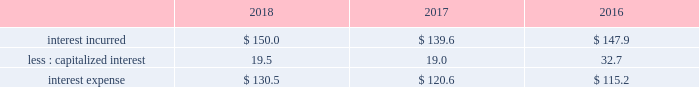Goodwill and intangible asset impairment charge during the third quarter of fiscal year 2017 , we determined that the goodwill and indefinite-lived intangible assets ( primarily acquired trade names ) associated with our latin america reporting unit of our industrial gases 2013 americas segment were impaired .
We recorded a noncash impairment charge of $ 162.1 ( $ 154.1 attributable to air products , after-tax , or $ .70 per share ) , which was driven by lower economic growth and profitability in the region .
This impairment charge has been excluded from segment results .
Refer to note 10 , goodwill , and note 11 , intangible assets , to the consolidated financial statements for additional information .
Other income ( expense ) , net items recorded to "other income ( expense ) , net" arise from transactions and events not directly related to our principal income earning activities .
The detail of "other income ( expense ) , net" is presented in note 23 , supplemental information , to the consolidated financial statements .
2018 vs .
2017 other income ( expense ) , net of $ 50.2 decreased $ 70.8 , primarily due to lower income from the transition services agreements with versum and evonik , lower income from the sale of assets and investments , lower favorable contract settlements , and an unfavorable foreign exchange impact .
2017 vs .
2016 other income ( expense ) , net of $ 121.0 increased $ 71.6 , primarily due to income from transition services agreements with versum and evonik , income from the sale of assets and investments , including a gain of $ 12.2 ( $ 7.6 after-tax , or $ .03 per share ) resulting from the sale of a parcel of land , and a favorable foreign exchange impact .
Interest expense .
2018 vs .
2017 interest incurred increased $ 10.4 as project financing associated with the lu'an joint venture and a higher average interest rate on the debt portfolio were partially offset by the impact from a lower average debt balance .
The change in capitalized interest was driven by an increase in the carrying value of projects under construction .
2017 vs .
2016 interest incurred decreased $ 8.3 as the impact from a lower average debt balance of $ 26 was partially offset by the impact from a higher average interest rate on the debt portfolio of $ 19 .
The change in capitalized interest was driven by a decrease in the carrying value of projects under construction , primarily as a result of our decision to exit from the efw business .
Other non-operating income ( expense ) , net 2018 vs .
2017 other non-operating income ( expense ) , net of $ 5.1 decreased $ 11.5 .
During the fourth quarter of fiscal year 2018 , we recognized a pension settlement loss of $ 43.7 ( $ 33.2 after-tax , or $ .15 per share ) that primarily resulted from the transfer of certain pension payment obligations to an insurer for our u.s .
Salaried and hourly plans through the purchase of an irrevocable , nonparticipating group annuity contract with plan assets .
For additional information , refer to note 16 , retirement benefits , to the consolidated financial statements .
This loss was partially offset by higher interest income on cash and cash items and short-term investments and lower other non-service pension expense .
The prior year pension expense included a settlement loss of $ 10.5 ( $ 6.6 after-tax , or $ .03 per share ) associated with the u.s .
Supplementary pension plan and a settlement benefit of $ 2.3 related to the disposition of emd and pmd. .
What was the increase in the interest expenses during 2017 and 2018? 
Rationale: it is the interest expense of 2018 divided by the 2017's then turned into a percentage.\\n
Computations: ((130.5 / 120.6) - 1)
Answer: 0.08209. 